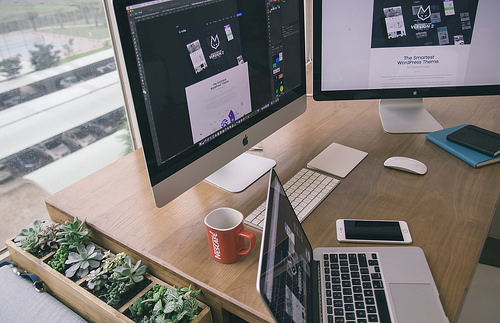<image>
Can you confirm if the window is behind the screen? Yes. From this viewpoint, the window is positioned behind the screen, with the screen partially or fully occluding the window. 